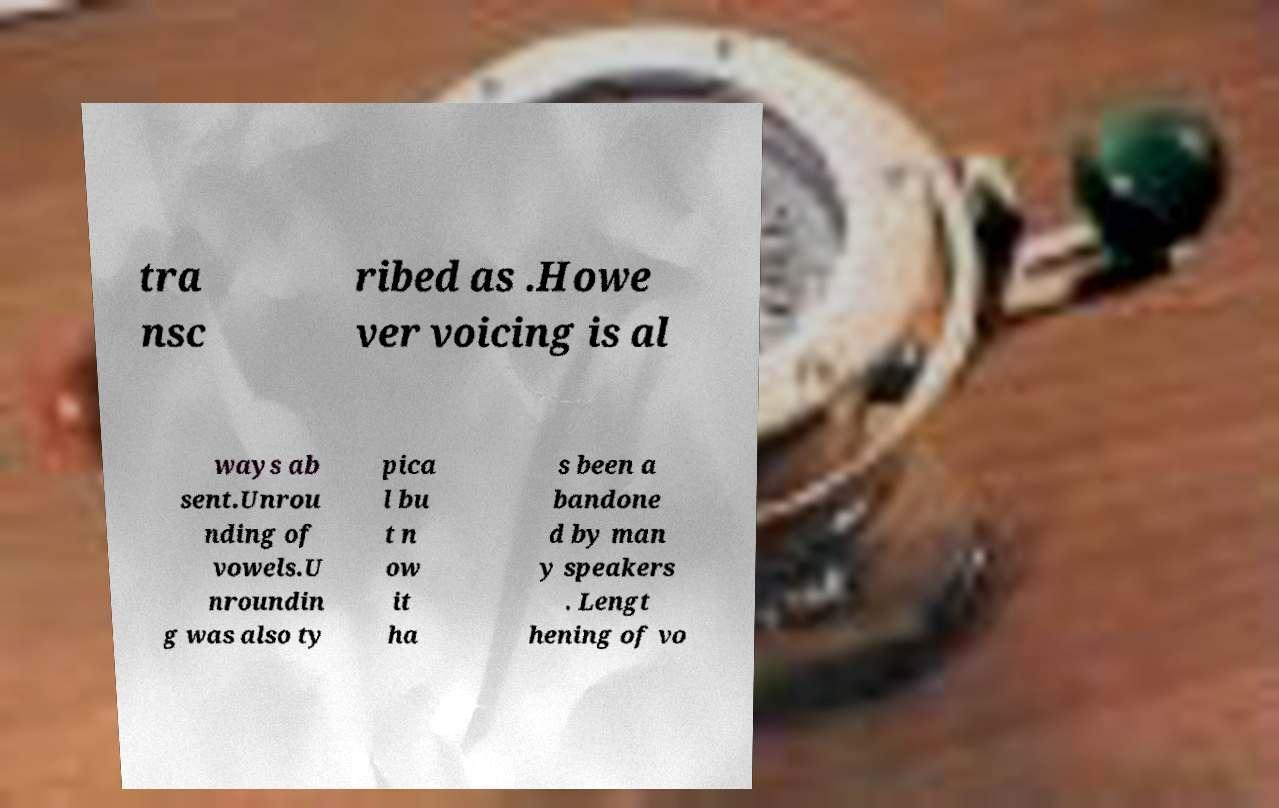Can you accurately transcribe the text from the provided image for me? tra nsc ribed as .Howe ver voicing is al ways ab sent.Unrou nding of vowels.U nroundin g was also ty pica l bu t n ow it ha s been a bandone d by man y speakers . Lengt hening of vo 